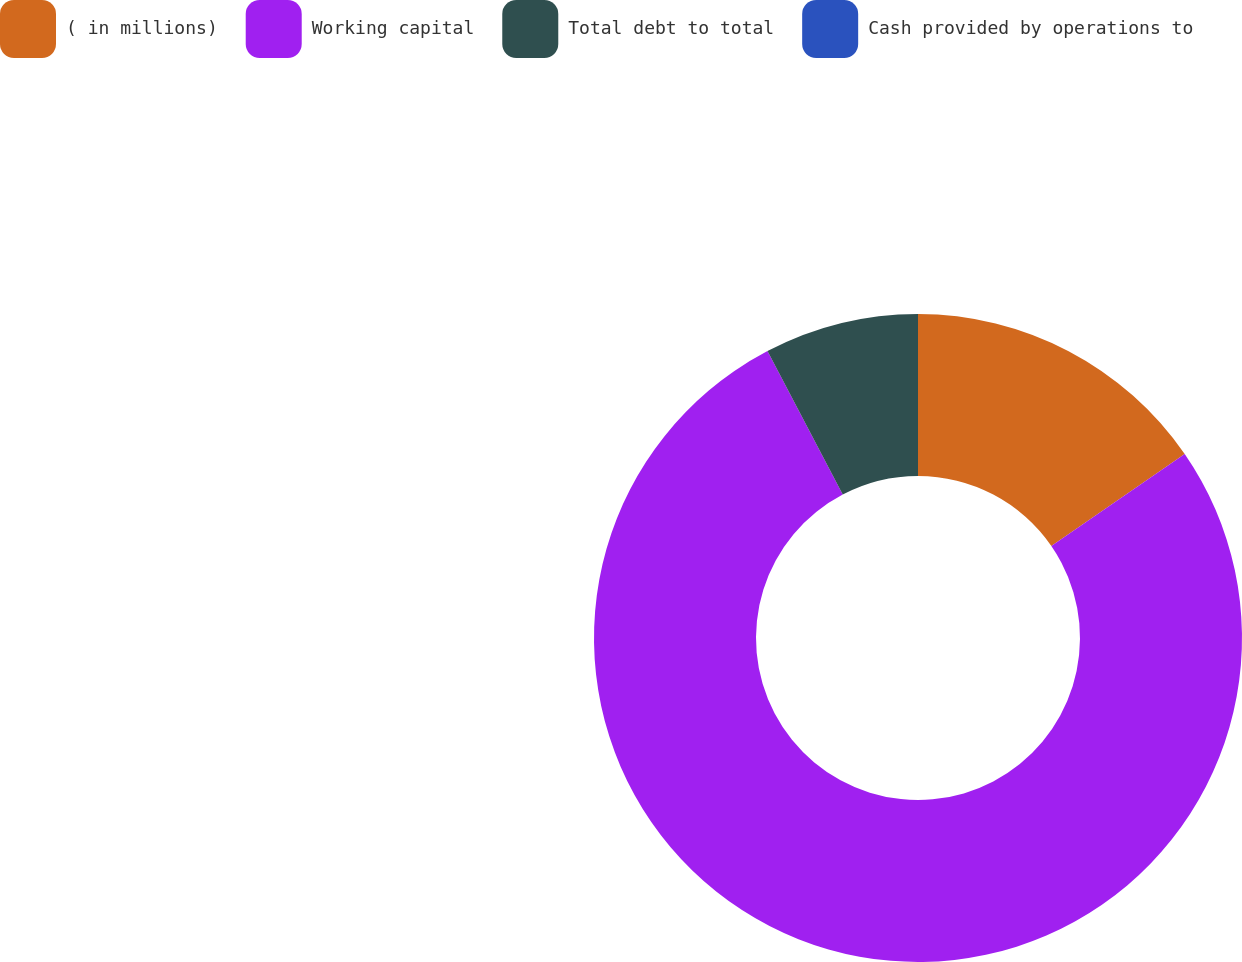<chart> <loc_0><loc_0><loc_500><loc_500><pie_chart><fcel>( in millions)<fcel>Working capital<fcel>Total debt to total<fcel>Cash provided by operations to<nl><fcel>15.39%<fcel>76.92%<fcel>7.69%<fcel>0.0%<nl></chart> 